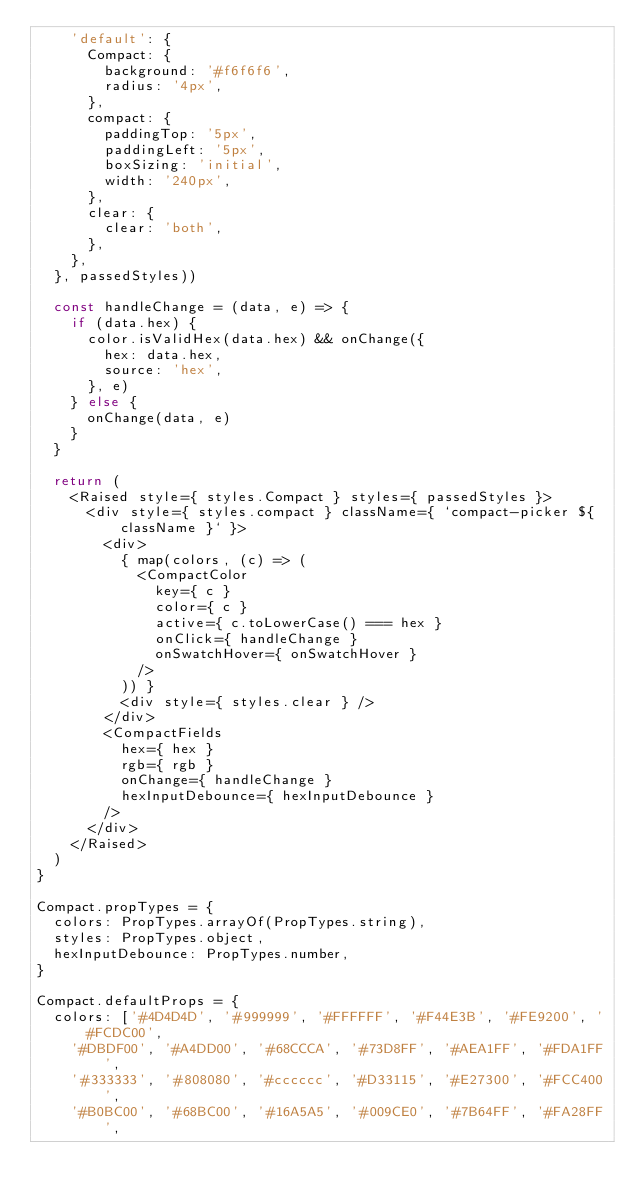Convert code to text. <code><loc_0><loc_0><loc_500><loc_500><_JavaScript_>    'default': {
      Compact: {
        background: '#f6f6f6',
        radius: '4px',
      },
      compact: {
        paddingTop: '5px',
        paddingLeft: '5px',
        boxSizing: 'initial',
        width: '240px',
      },
      clear: {
        clear: 'both',
      },
    },
  }, passedStyles))

  const handleChange = (data, e) => {
    if (data.hex) {
      color.isValidHex(data.hex) && onChange({
        hex: data.hex,
        source: 'hex',
      }, e)
    } else {
      onChange(data, e)
    }
  }

  return (
    <Raised style={ styles.Compact } styles={ passedStyles }>
      <div style={ styles.compact } className={ `compact-picker ${ className }` }>
        <div>
          { map(colors, (c) => (
            <CompactColor
              key={ c }
              color={ c }
              active={ c.toLowerCase() === hex }
              onClick={ handleChange }
              onSwatchHover={ onSwatchHover }
            />
          )) }
          <div style={ styles.clear } />
        </div>
        <CompactFields
          hex={ hex }
          rgb={ rgb }
          onChange={ handleChange }
          hexInputDebounce={ hexInputDebounce }
        />
      </div>
    </Raised>
  )
}

Compact.propTypes = {
  colors: PropTypes.arrayOf(PropTypes.string),
  styles: PropTypes.object,
  hexInputDebounce: PropTypes.number,
}

Compact.defaultProps = {
  colors: ['#4D4D4D', '#999999', '#FFFFFF', '#F44E3B', '#FE9200', '#FCDC00',
    '#DBDF00', '#A4DD00', '#68CCCA', '#73D8FF', '#AEA1FF', '#FDA1FF',
    '#333333', '#808080', '#cccccc', '#D33115', '#E27300', '#FCC400',
    '#B0BC00', '#68BC00', '#16A5A5', '#009CE0', '#7B64FF', '#FA28FF',</code> 